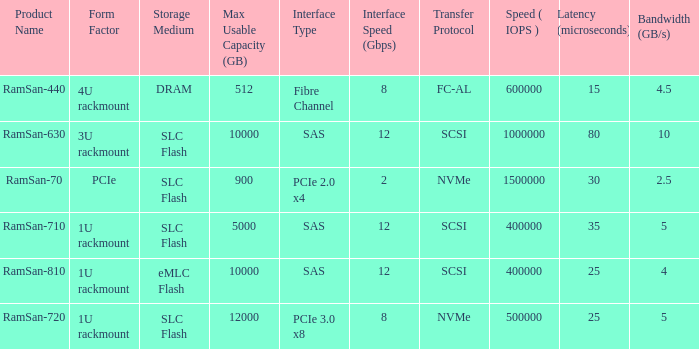List the number of ramsan-720 hard drives? 1.0. 